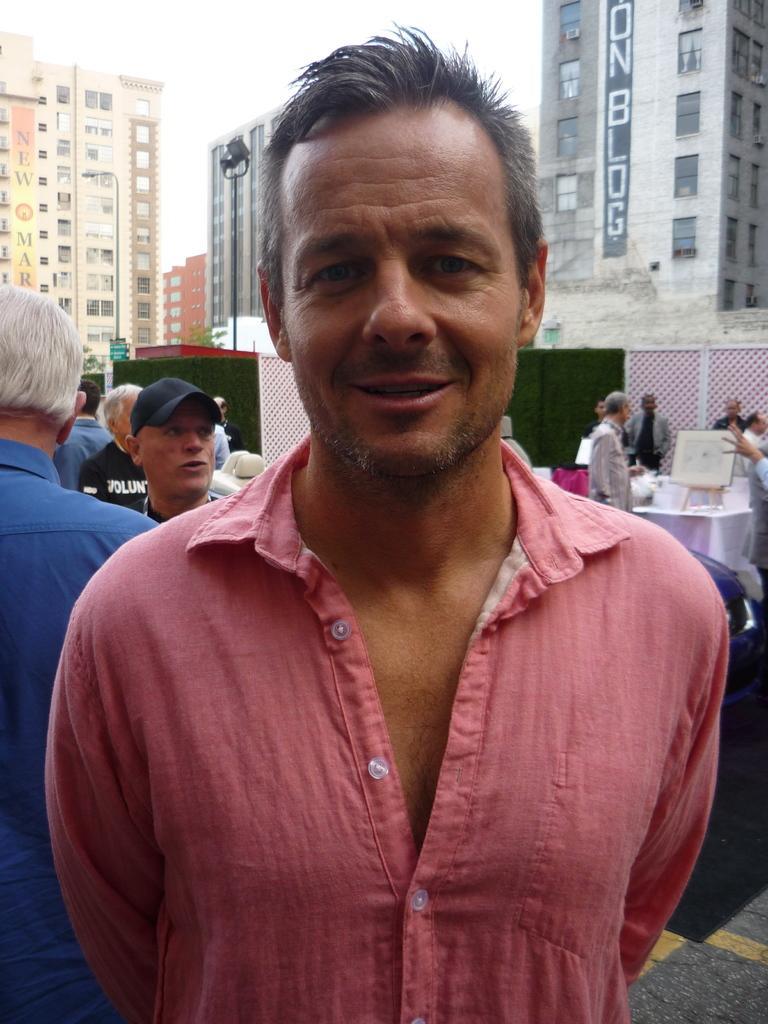Describe this image in one or two sentences. There is a person in pink color shirt, smiling and standing on the floor. In the background, there are other persons standing, there are tables, which are covered with white color clothes, on which, there are some objects, there are buildings which are having glass windows and clouds in the sky. 